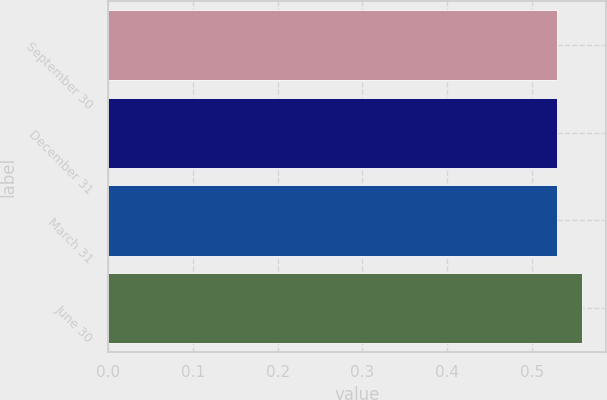Convert chart to OTSL. <chart><loc_0><loc_0><loc_500><loc_500><bar_chart><fcel>September 30<fcel>December 31<fcel>March 31<fcel>June 30<nl><fcel>0.53<fcel>0.53<fcel>0.53<fcel>0.56<nl></chart> 